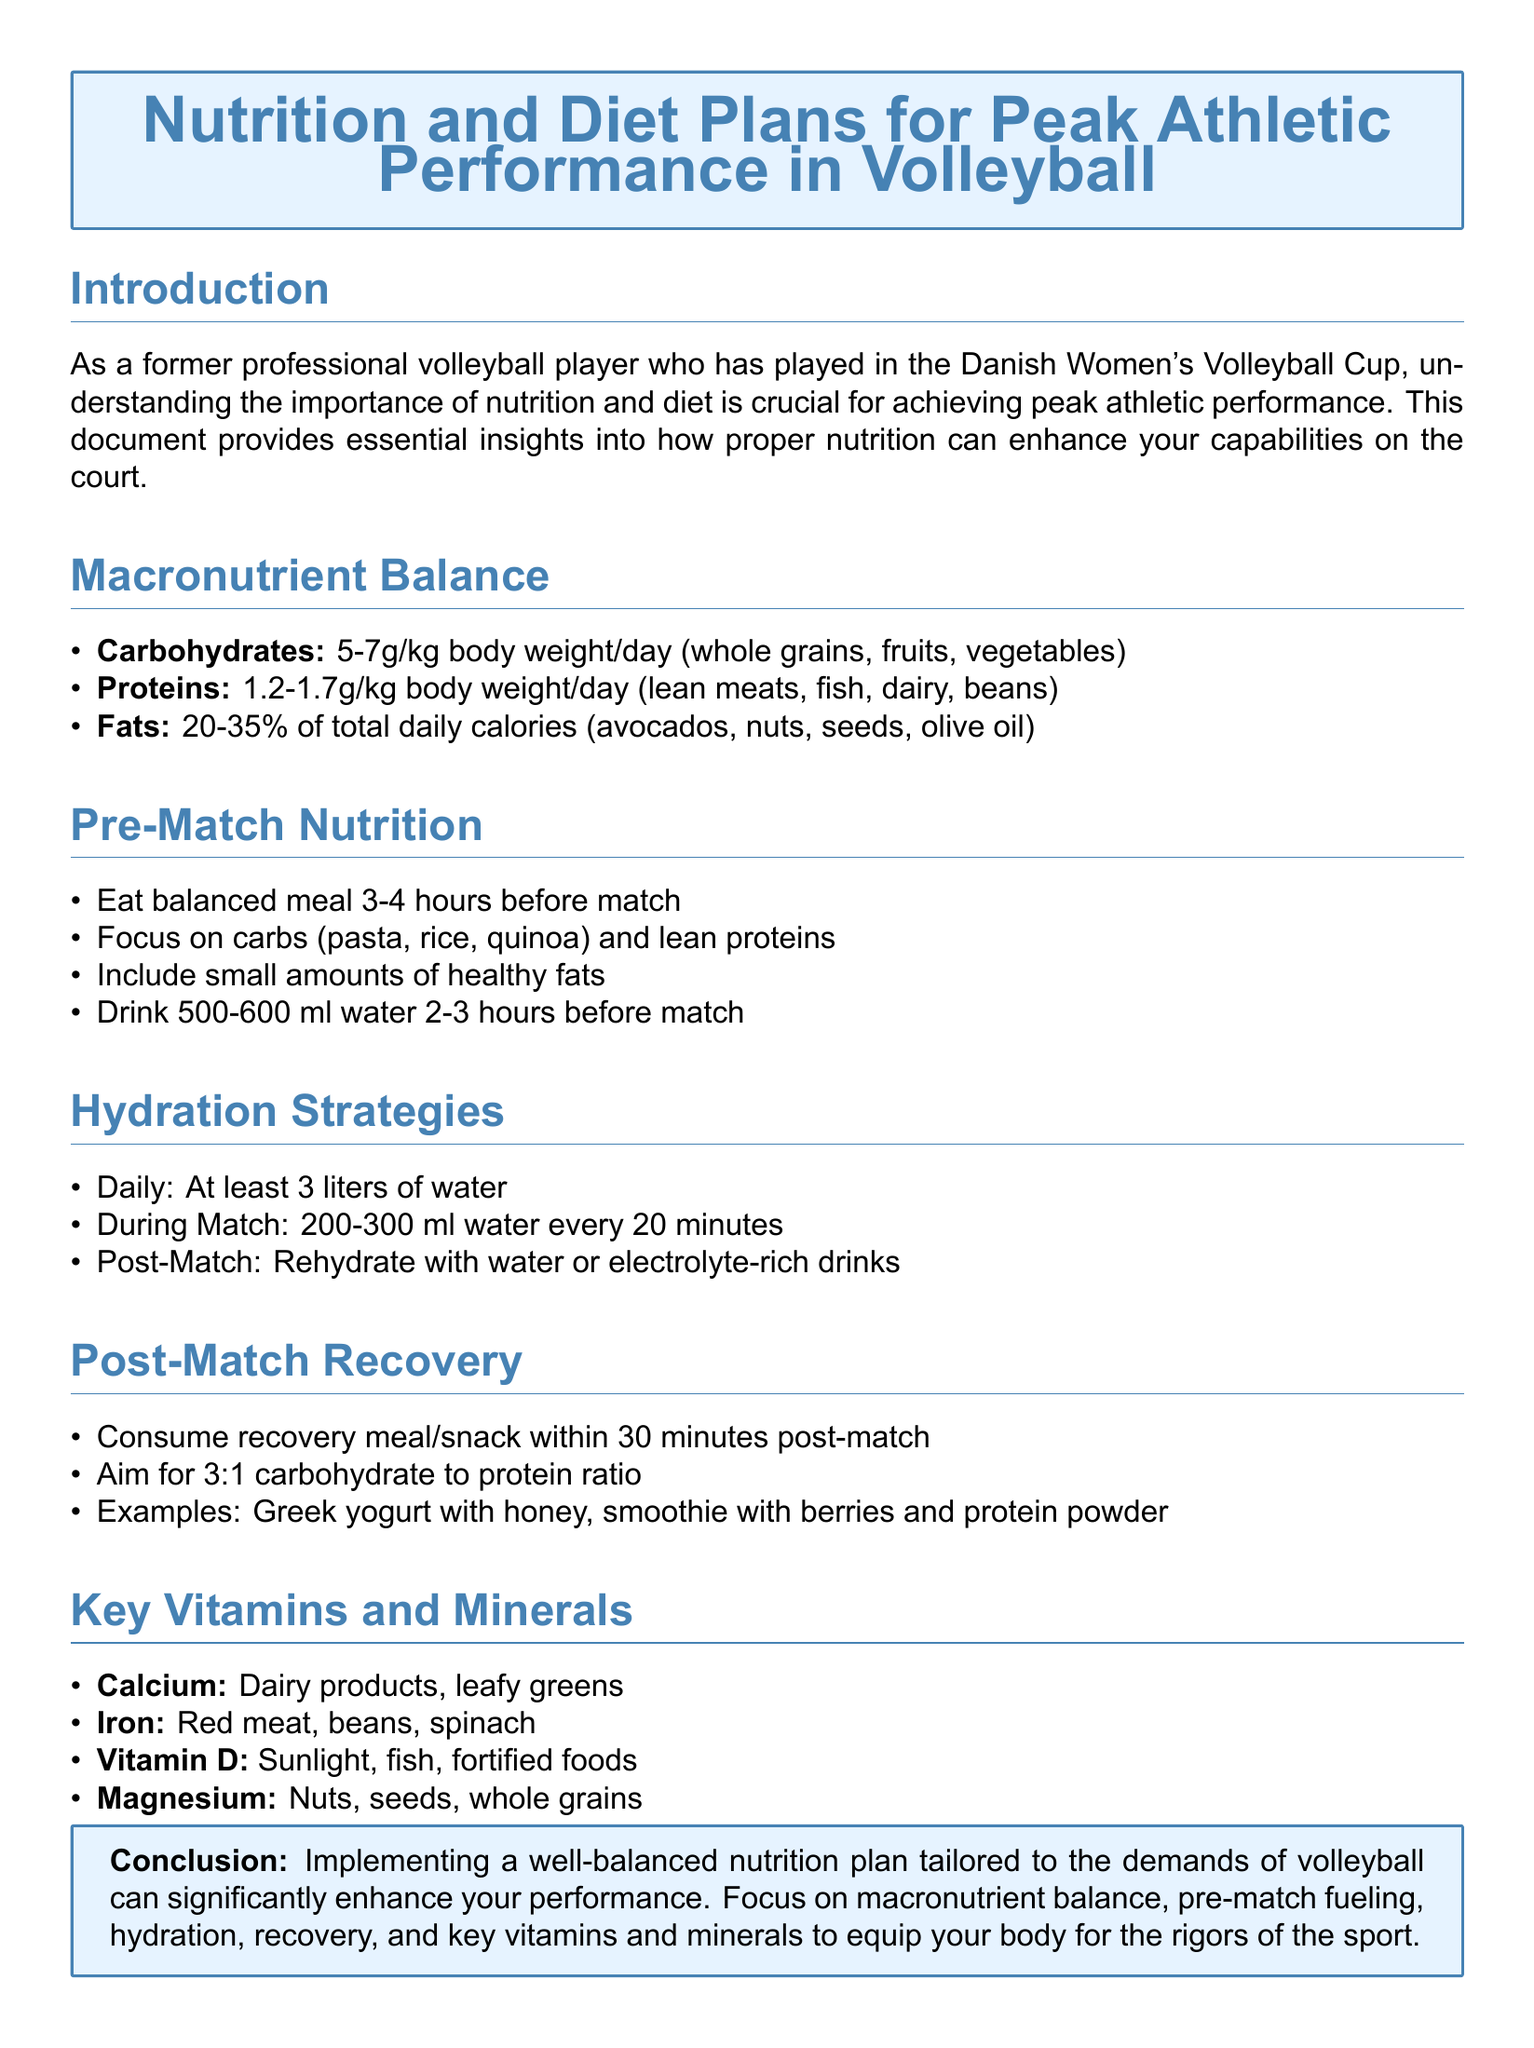What is the recommended daily intake of carbohydrates per kg of body weight? The document indicates that carbohydrates should be consumed at a rate of 5-7g/kg body weight per day.
Answer: 5-7g/kg What type of meal should be eaten 3-4 hours before a match? The document states to eat a balanced meal focusing on carbohydrates and lean proteins before a match.
Answer: Balanced meal How much water should be consumed during a match? According to the document, 200-300 ml of water should be consumed every 20 minutes during the match.
Answer: 200-300 ml What is the recommended carbohydrate to protein ratio for post-match recovery? The document mentions aiming for a 3:1 carbohydrate to protein ratio in the post-match recovery meal.
Answer: 3:1 Which vitamin is indicated to be sourced from sunlight? The document lists Vitamin D as one sourced from sunlight.
Answer: Vitamin D What is the specific amount of water recommended daily? The document specifies that at least 3 liters of water should be consumed daily.
Answer: 3 liters What is a suitable post-match snack mentioned? The document provides examples like Greek yogurt with honey as a suitable post-match snack.
Answer: Greek yogurt with honey What percentage of total daily calories should fats comprise? The document states that fats should comprise 20-35% of total daily calories.
Answer: 20-35% What is the emphasis of this homework document? The emphasis of the document is on nutrition and diet plans for peak athletic performance in volleyball.
Answer: Nutrition and diet plans 